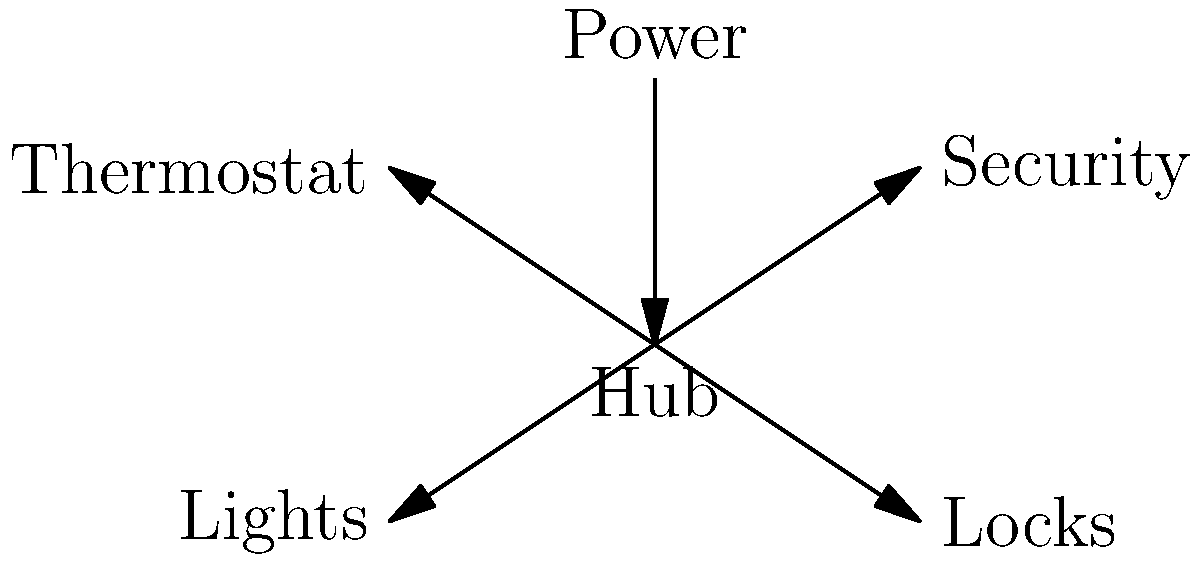In the given smart home wiring diagram, which component serves as the central point of communication for all other devices, and what potential issue could arise if this component fails? To answer this question, let's analyze the diagram step-by-step:

1. Identify the central component: The diagram shows a central node labeled "Hub" with connections to all other devices.

2. Trace connections: We can see arrows pointing from the Hub to:
   - Thermostat
   - Security system
   - Lights
   - Locks

3. Observe power flow: There's an arrow from the "Power" source to the Hub, indicating that the Hub is powered and likely distributes power or signals to other devices.

4. Understand the Hub's role: Based on its central position and connections, the Hub acts as the main communication point for all smart devices in the home.

5. Consider failure scenarios: If the Hub fails:
   - Communication between devices would be disrupted
   - Remote control of devices might become impossible
   - Automated routines and schedules could fail
   - The entire smart home system could become non-functional

Therefore, the Hub is the critical component in this smart home system, and its failure would likely result in a complete system breakdown, rendering all connected smart devices unable to communicate or function as part of the integrated system.
Answer: The Hub; system-wide communication failure 